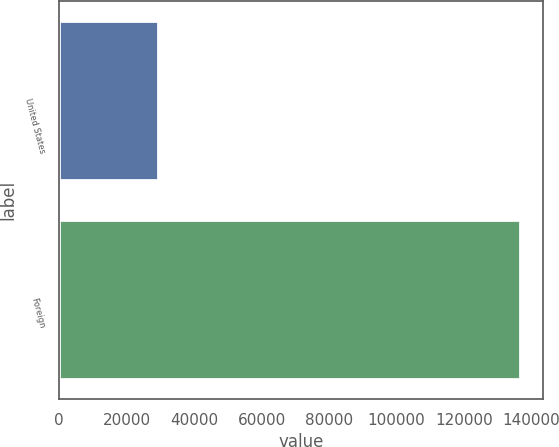Convert chart. <chart><loc_0><loc_0><loc_500><loc_500><bar_chart><fcel>United States<fcel>Foreign<nl><fcel>29377<fcel>136422<nl></chart> 